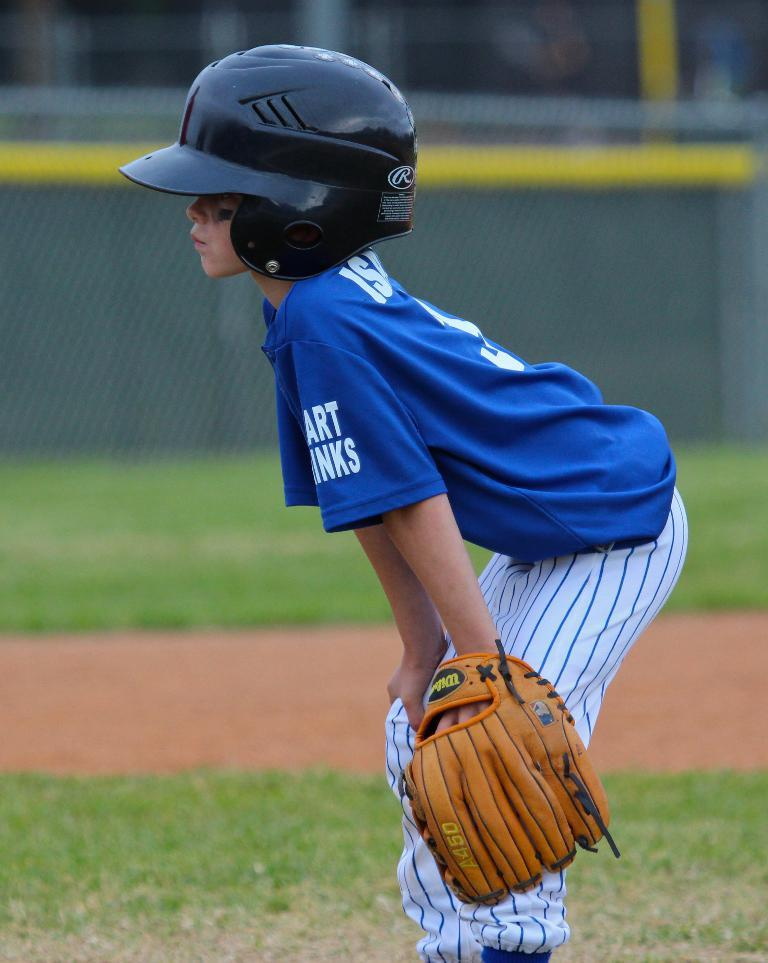Who is in the image? There is a boy in the image. What is the boy doing in the image? The boy is standing in the image. What is the boy wearing on his head? The boy is wearing a helmet on his head. What is the boy wearing on his hand? The boy is wearing a glove on his hand. What type of surface is under the boy's feet? There is grass on the ground in the image. What color is the boy's t-shirt? The boy is wearing a blue t-shirt. What color is the boy's helmet? The boy is wearing a black helmet. What card game is the boy playing in the image? There is no card game present in the image; the boy is wearing a helmet and a glove, which suggests he might be participating in a sport or activity. 